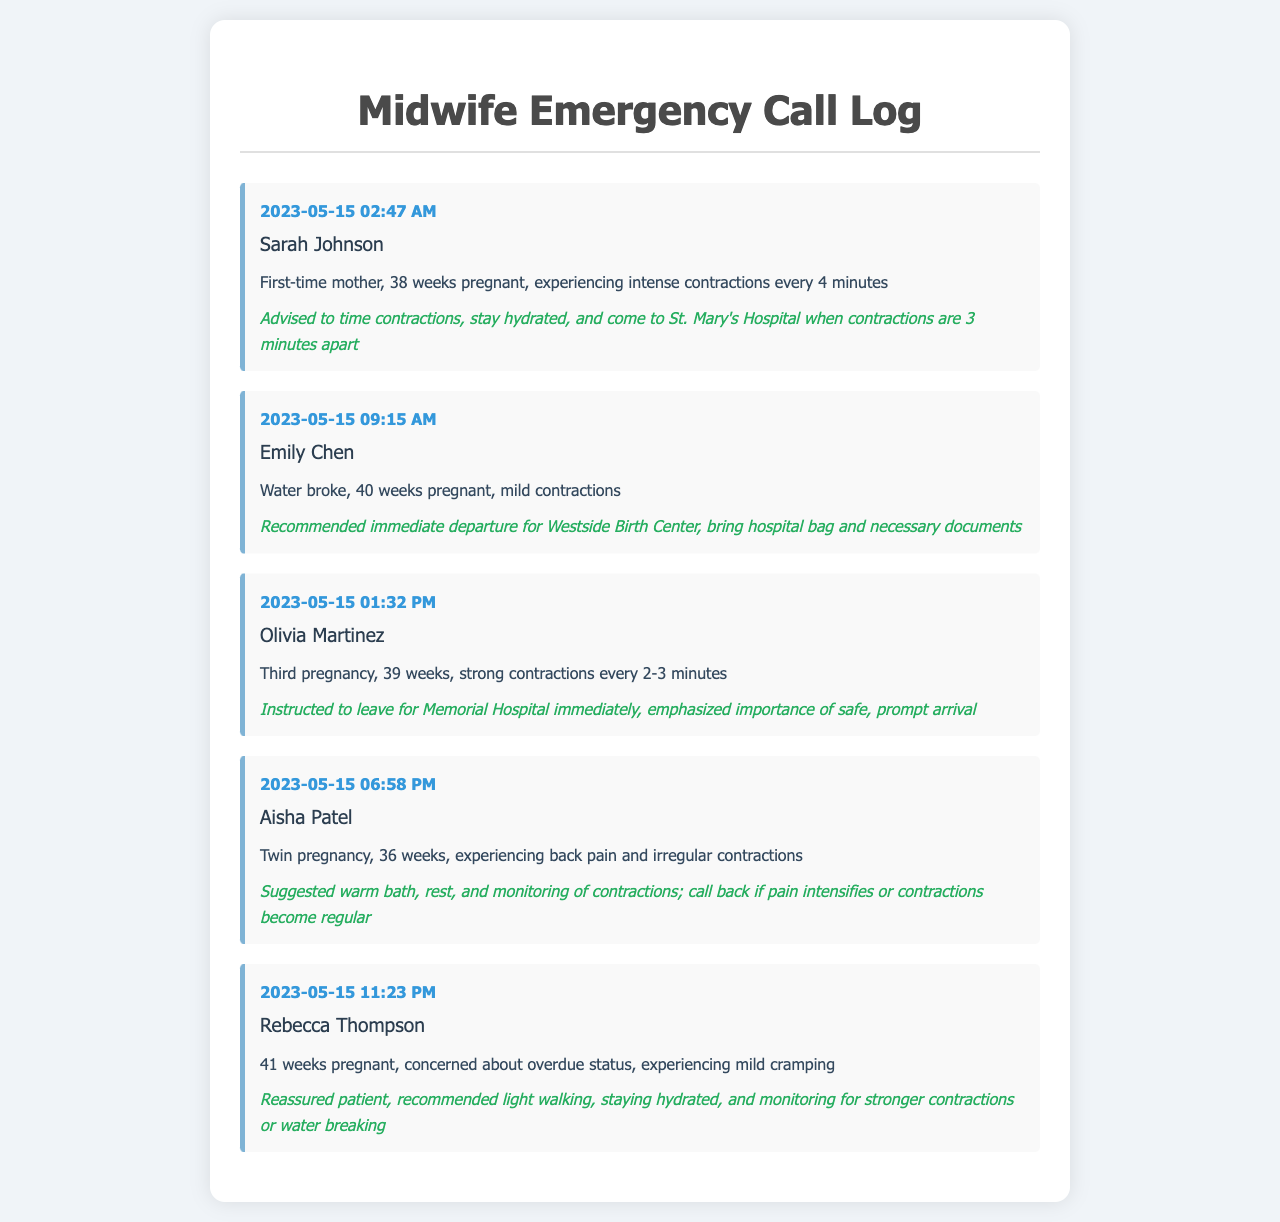what is the name of the first patient in the logs? The first patient listed in the logs is Sarah Johnson.
Answer: Sarah Johnson what time did Olivia Martinez call? The timestamp for Olivia Martinez's call is 2023-05-15 01:32 PM.
Answer: 01:32 PM how many weeks pregnant is Aisha Patel? Aisha Patel is 36 weeks pregnant according to the summary.
Answer: 36 weeks what advice was given to Emily Chen? Emily Chen was advised to immediately depart for Westside Birth Center and to bring her hospital bag and necessary documents.
Answer: Immediate departure for Westside Birth Center how often were Olivia Martinez's contractions? Olivia Martinez was experiencing strong contractions every 2-3 minutes.
Answer: Every 2-3 minutes which patient is concerned about overdue status? The patient concerned about overdue status is Rebecca Thompson.
Answer: Rebecca Thompson how many minutes apart were Sarah Johnson's contractions advised to be observed for travel? Sarah Johnson's contractions were advised to be timed, focusing on when they are 3 minutes apart for travel.
Answer: 3 minutes what kind of pregnancy does Aisha Patel have? Aisha Patel has a twin pregnancy as indicated in the log.
Answer: Twin pregnancy 